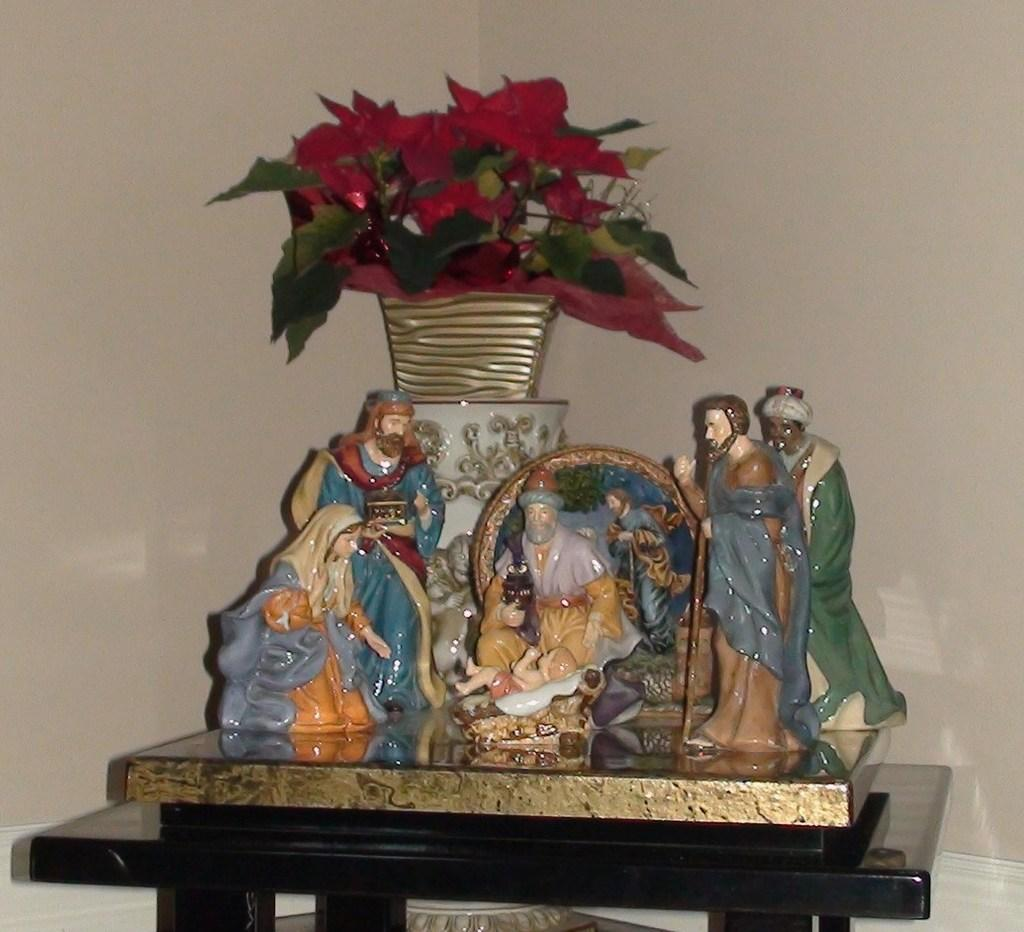What is the main object in the center of the image? There is a table in the middle of the image. What is placed on the table? There are idols and a flower vase on the table. What can be seen behind the table? There is a wall visible in the image. How does the beginner feel while observing the idols in the image? There is no information about a beginner or their feelings in the image, as it only shows a table with idols and a flower vase on it. 